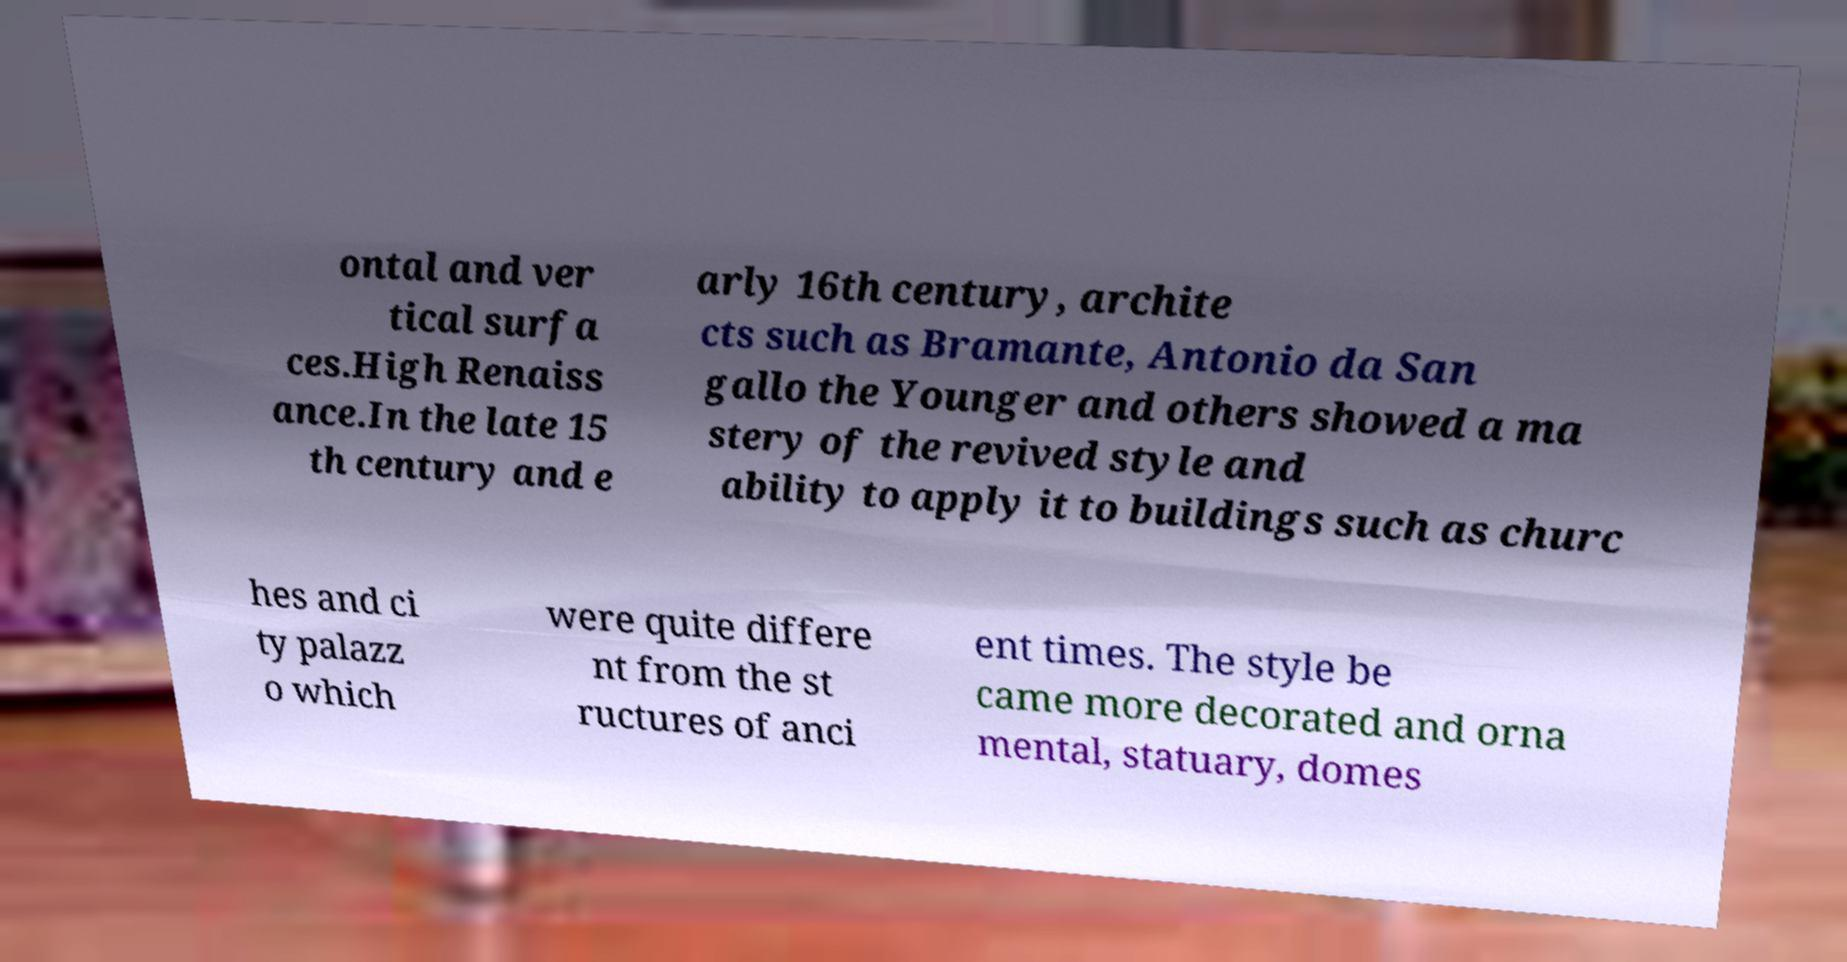Could you assist in decoding the text presented in this image and type it out clearly? ontal and ver tical surfa ces.High Renaiss ance.In the late 15 th century and e arly 16th century, archite cts such as Bramante, Antonio da San gallo the Younger and others showed a ma stery of the revived style and ability to apply it to buildings such as churc hes and ci ty palazz o which were quite differe nt from the st ructures of anci ent times. The style be came more decorated and orna mental, statuary, domes 